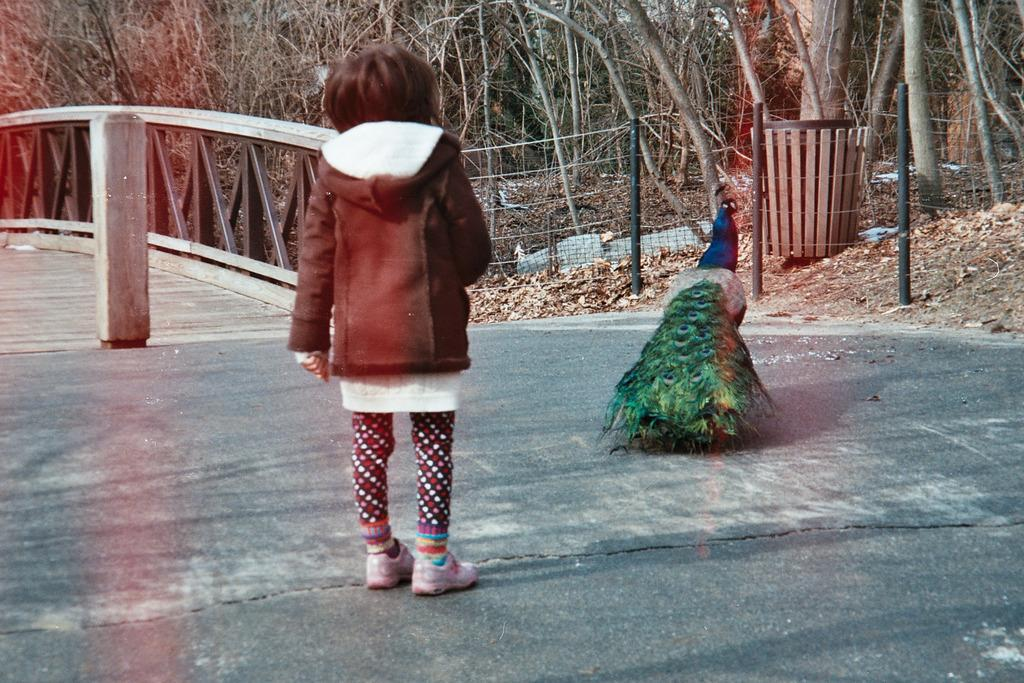Who or what is present in the image? There is a person and a peacock in the image. What can be seen in the background of the image? There is a fence and trees in the background of the image. What type of machine is being used by the person in the image? There is no machine present in the image; it features a person and a peacock. How does the peacock provide the answer to the question in the image? There is: There is no question or answer provided in the image, as it only shows a person and a peacock. 